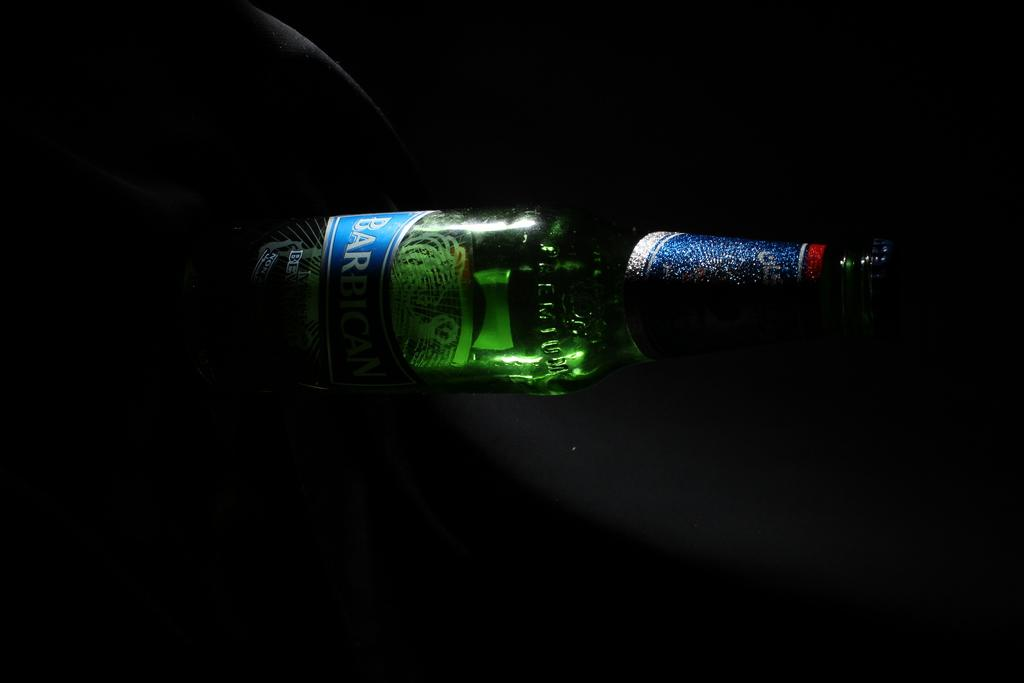<image>
Summarize the visual content of the image. A Barbig bottle of beer lays sideways on a table. 